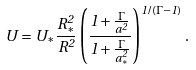Convert formula to latex. <formula><loc_0><loc_0><loc_500><loc_500>U = U _ { \ast } \frac { R ^ { 2 } _ { \ast } } { R ^ { 2 } } \left ( \frac { 1 + \frac { \Gamma } { a ^ { 2 } } } { 1 + \frac { \Gamma } { a ^ { 2 } _ { \ast } } } \right ) ^ { 1 / ( \Gamma - 1 ) } .</formula> 